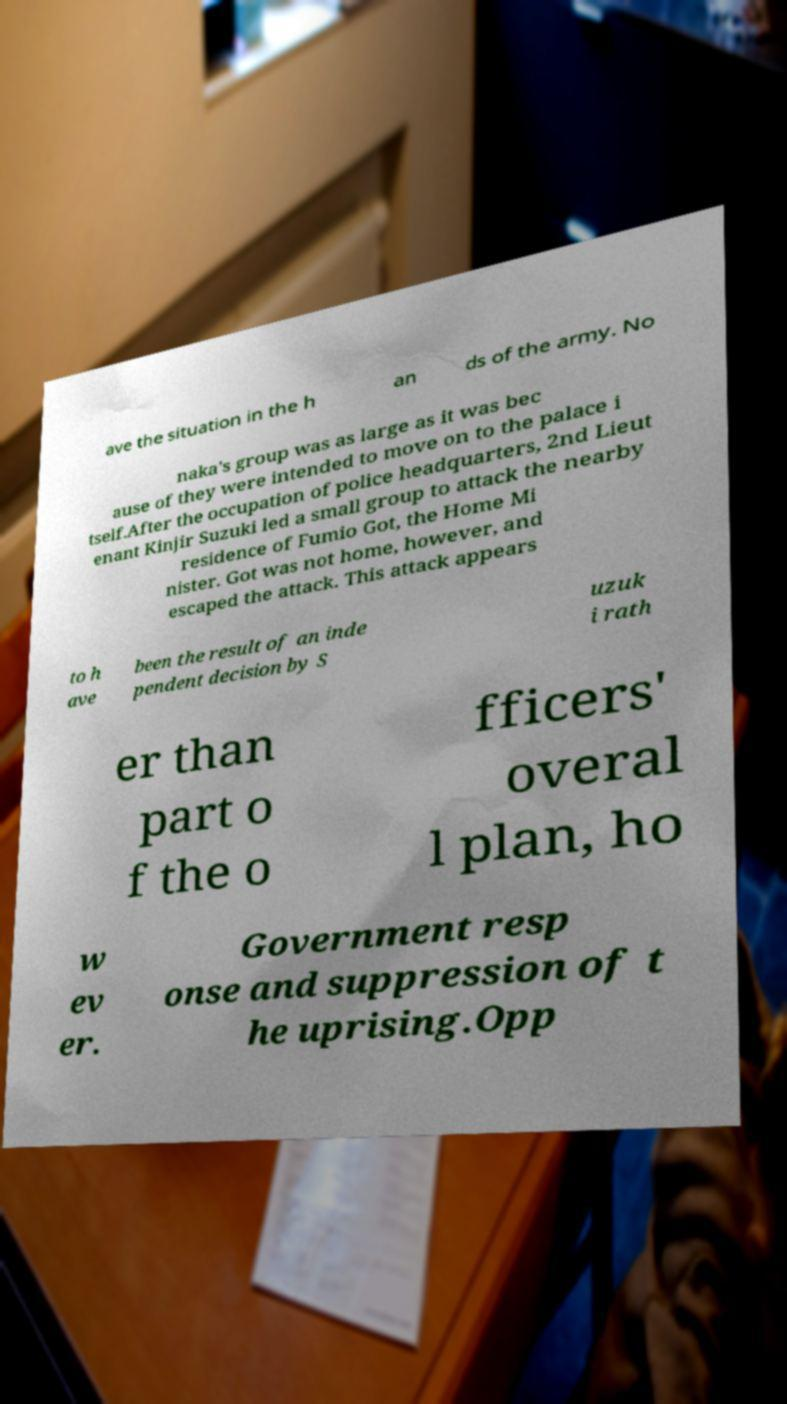Could you extract and type out the text from this image? ave the situation in the h an ds of the army. No naka's group was as large as it was bec ause of they were intended to move on to the palace i tself.After the occupation of police headquarters, 2nd Lieut enant Kinjir Suzuki led a small group to attack the nearby residence of Fumio Got, the Home Mi nister. Got was not home, however, and escaped the attack. This attack appears to h ave been the result of an inde pendent decision by S uzuk i rath er than part o f the o fficers' overal l plan, ho w ev er. Government resp onse and suppression of t he uprising.Opp 